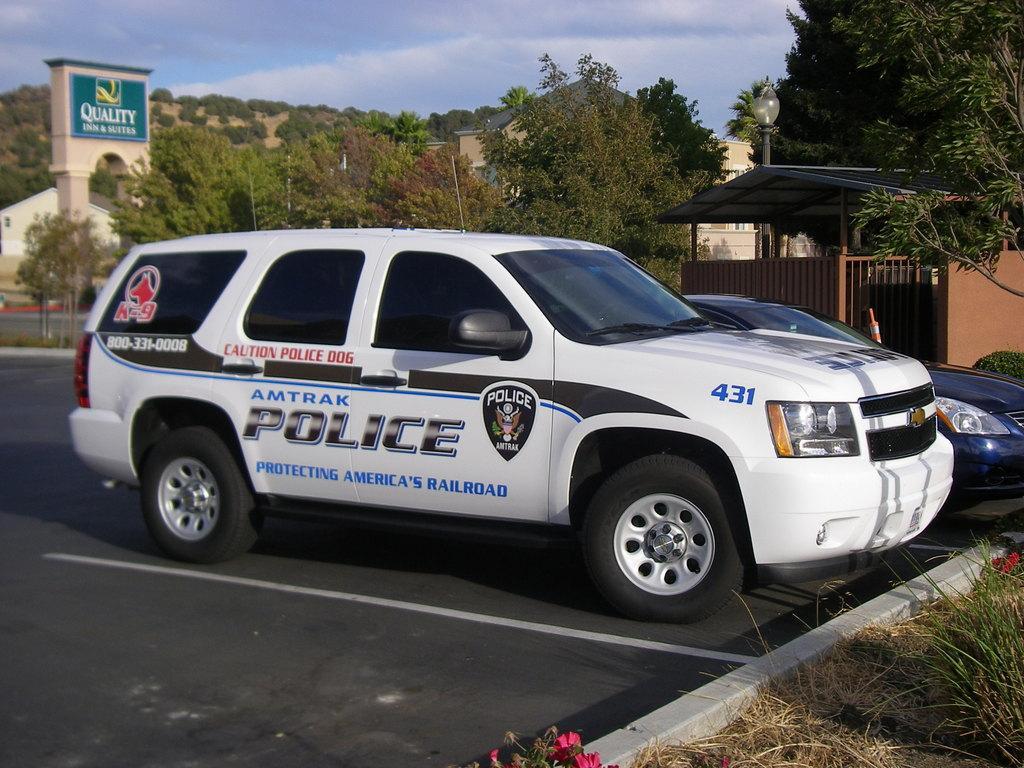Describe this image in one or two sentences. In the foreground of the image we can see a police car. In the middle of the image we can see trees and the arch. On the top of the image we can see the sky. 